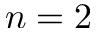Convert formula to latex. <formula><loc_0><loc_0><loc_500><loc_500>n = 2</formula> 